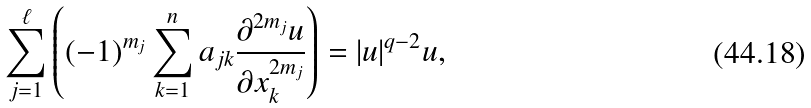<formula> <loc_0><loc_0><loc_500><loc_500>\sum _ { j = 1 } ^ { \ell } \left ( ( - 1 ) ^ { m _ { j } } \sum _ { k = 1 } ^ { n } a _ { j k } \frac { \partial ^ { 2 m _ { j } } u } { \partial x _ { k } ^ { 2 m _ { j } } } \right ) = | u | ^ { q - 2 } u ,</formula> 